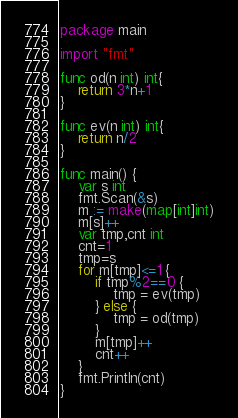Convert code to text. <code><loc_0><loc_0><loc_500><loc_500><_Go_>package main

import "fmt"

func od(n int) int{
	return 3*n+1
}

func ev(n int) int{
	return n/2
}

func main() {
	var s int
	fmt.Scan(&s)
	m := make(map[int]int)
	m[s]++
	var tmp,cnt int
	cnt=1
	tmp=s
	for m[tmp]<=1 {
		if tmp%2==0 {
			tmp = ev(tmp)
		} else {
			tmp = od(tmp)
		}
		m[tmp]++
		cnt++
	}
	fmt.Println(cnt)
}</code> 